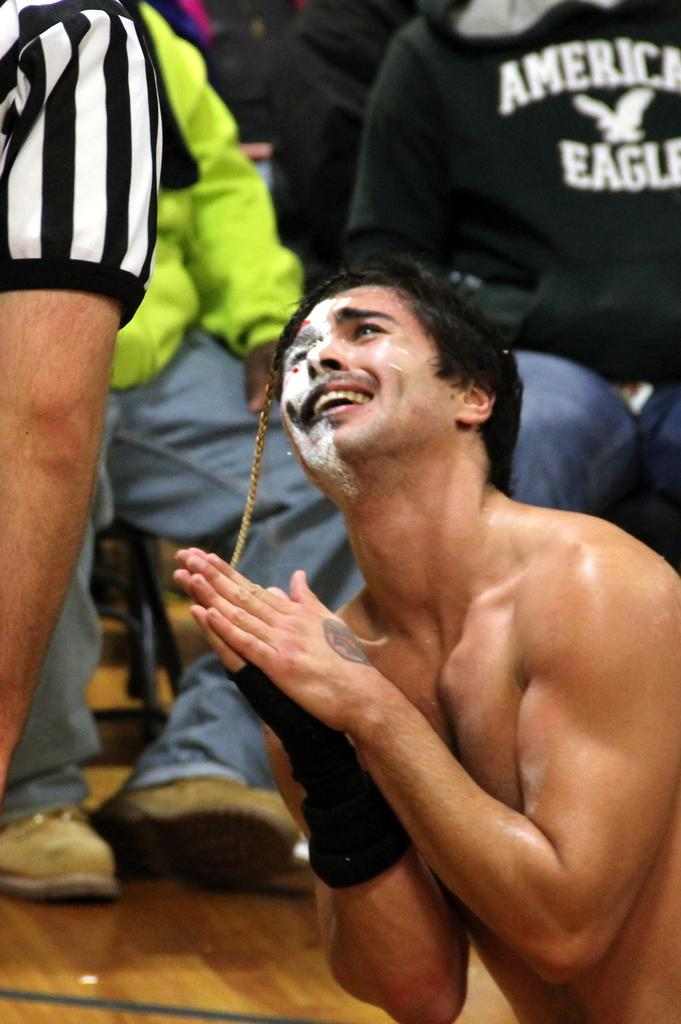<image>
Summarize the visual content of the image. A shirtless man is posing with his palms pressed in front of a person wearing American eagle sweatshirt. 